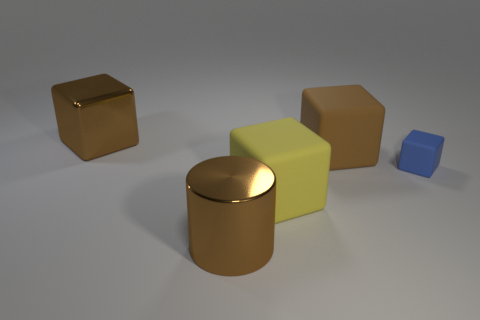What shape is the large brown shiny thing to the right of the big brown thing on the left side of the big cylinder that is on the left side of the tiny matte thing? cylinder 